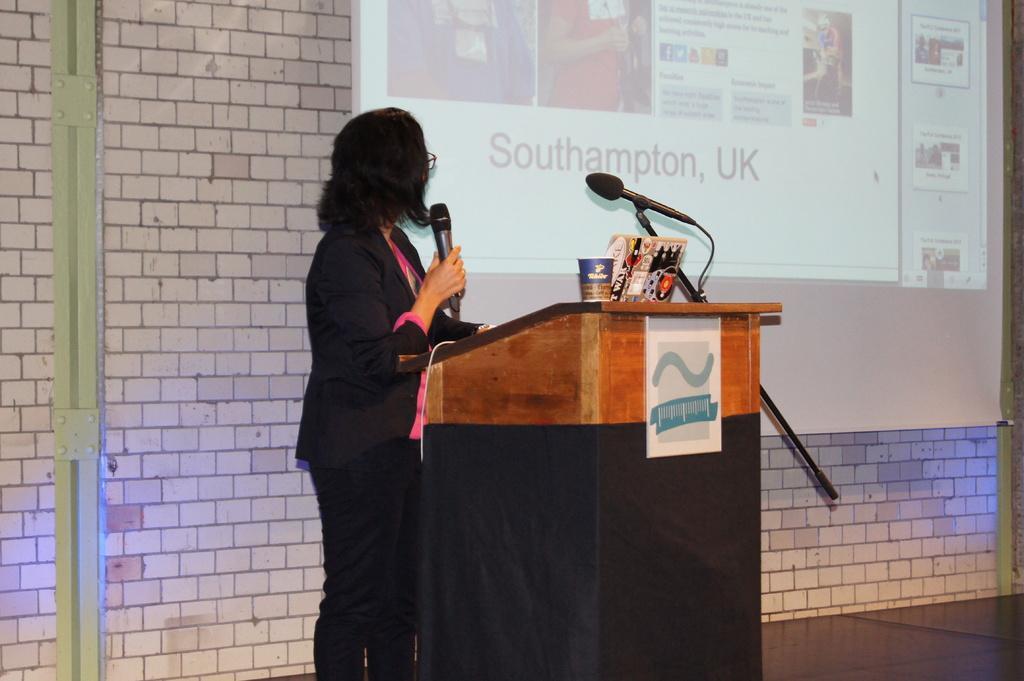Could you give a brief overview of what you see in this image? Here we can see a woman is standing on the floor, and holding a microphone in her hands, and at back here is the wall made of bricks, and here is the projector. 